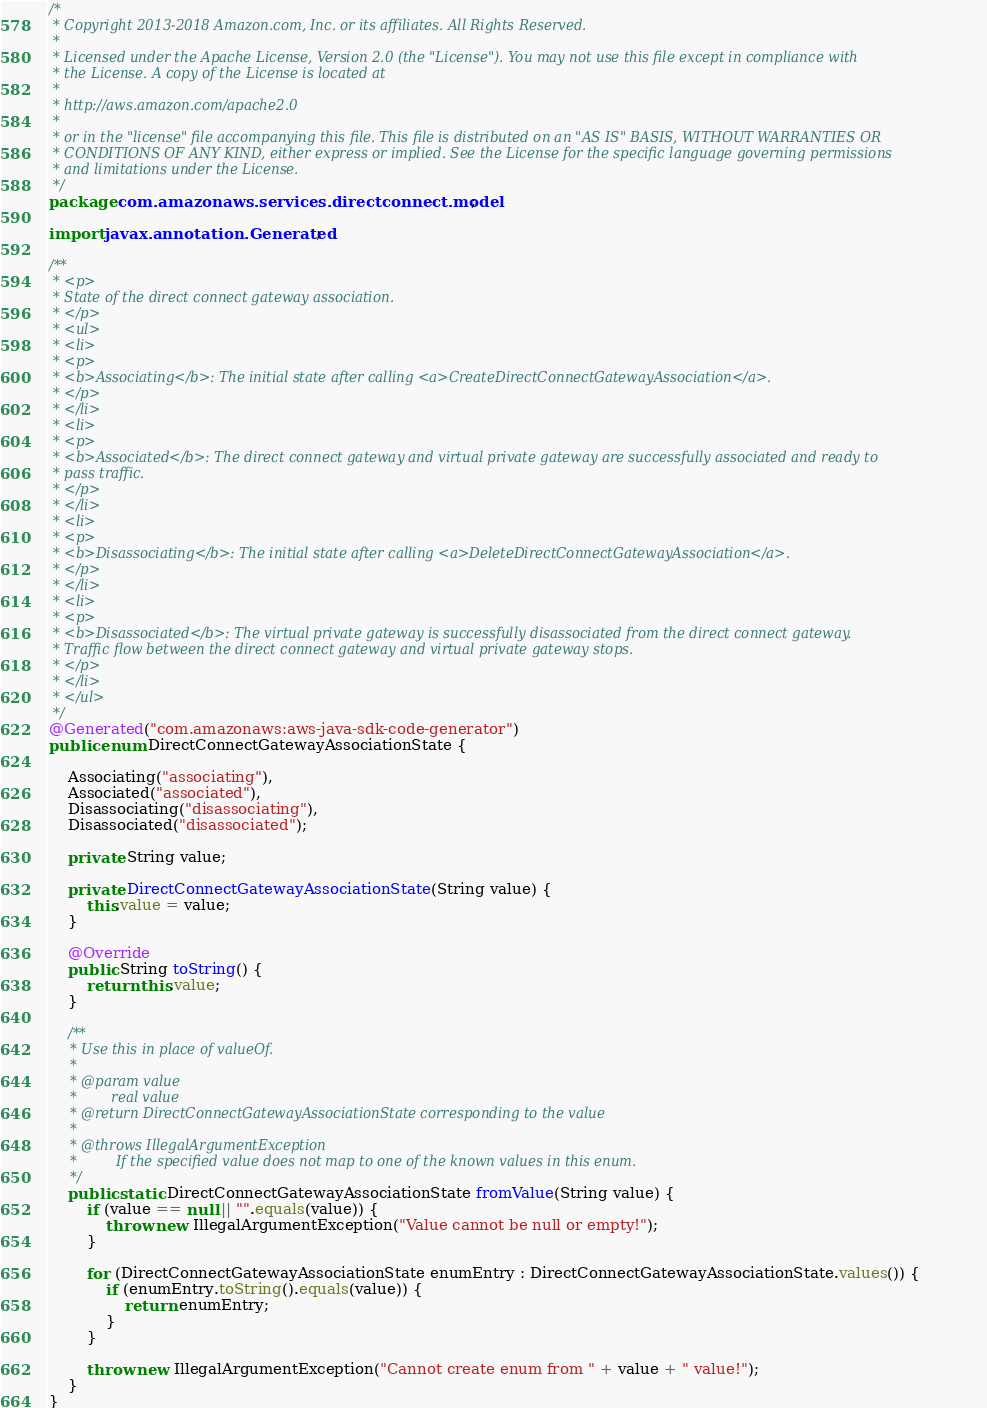<code> <loc_0><loc_0><loc_500><loc_500><_Java_>/*
 * Copyright 2013-2018 Amazon.com, Inc. or its affiliates. All Rights Reserved.
 * 
 * Licensed under the Apache License, Version 2.0 (the "License"). You may not use this file except in compliance with
 * the License. A copy of the License is located at
 * 
 * http://aws.amazon.com/apache2.0
 * 
 * or in the "license" file accompanying this file. This file is distributed on an "AS IS" BASIS, WITHOUT WARRANTIES OR
 * CONDITIONS OF ANY KIND, either express or implied. See the License for the specific language governing permissions
 * and limitations under the License.
 */
package com.amazonaws.services.directconnect.model;

import javax.annotation.Generated;

/**
 * <p>
 * State of the direct connect gateway association.
 * </p>
 * <ul>
 * <li>
 * <p>
 * <b>Associating</b>: The initial state after calling <a>CreateDirectConnectGatewayAssociation</a>.
 * </p>
 * </li>
 * <li>
 * <p>
 * <b>Associated</b>: The direct connect gateway and virtual private gateway are successfully associated and ready to
 * pass traffic.
 * </p>
 * </li>
 * <li>
 * <p>
 * <b>Disassociating</b>: The initial state after calling <a>DeleteDirectConnectGatewayAssociation</a>.
 * </p>
 * </li>
 * <li>
 * <p>
 * <b>Disassociated</b>: The virtual private gateway is successfully disassociated from the direct connect gateway.
 * Traffic flow between the direct connect gateway and virtual private gateway stops.
 * </p>
 * </li>
 * </ul>
 */
@Generated("com.amazonaws:aws-java-sdk-code-generator")
public enum DirectConnectGatewayAssociationState {

    Associating("associating"),
    Associated("associated"),
    Disassociating("disassociating"),
    Disassociated("disassociated");

    private String value;

    private DirectConnectGatewayAssociationState(String value) {
        this.value = value;
    }

    @Override
    public String toString() {
        return this.value;
    }

    /**
     * Use this in place of valueOf.
     *
     * @param value
     *        real value
     * @return DirectConnectGatewayAssociationState corresponding to the value
     *
     * @throws IllegalArgumentException
     *         If the specified value does not map to one of the known values in this enum.
     */
    public static DirectConnectGatewayAssociationState fromValue(String value) {
        if (value == null || "".equals(value)) {
            throw new IllegalArgumentException("Value cannot be null or empty!");
        }

        for (DirectConnectGatewayAssociationState enumEntry : DirectConnectGatewayAssociationState.values()) {
            if (enumEntry.toString().equals(value)) {
                return enumEntry;
            }
        }

        throw new IllegalArgumentException("Cannot create enum from " + value + " value!");
    }
}
</code> 